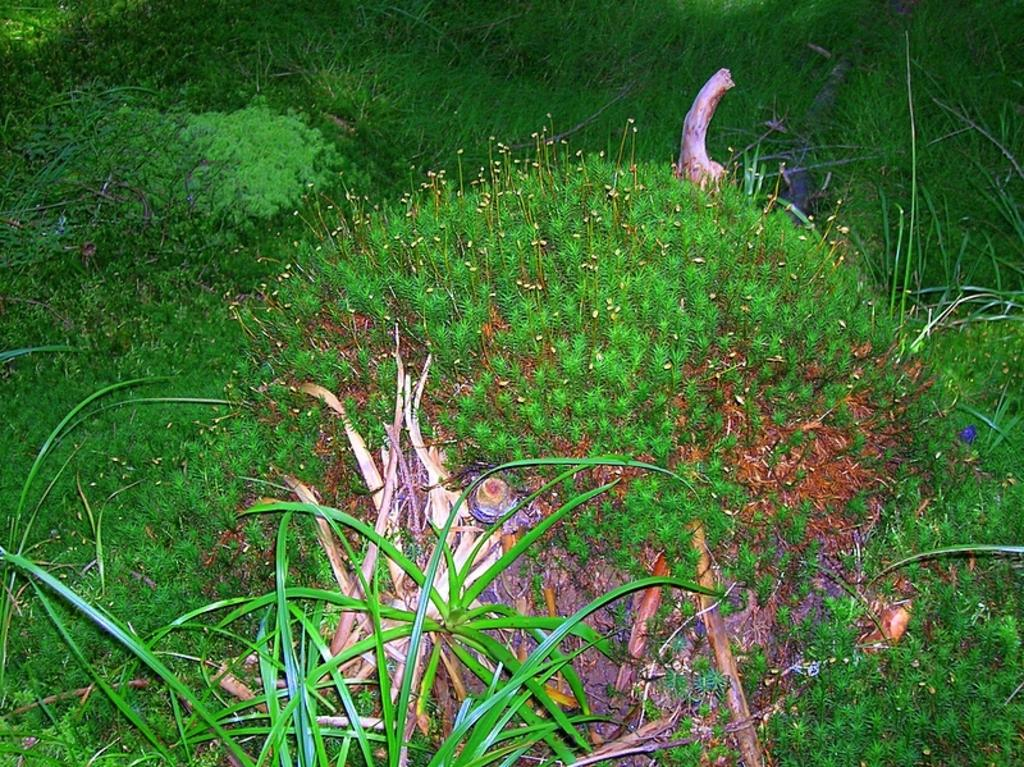What type of vegetation can be seen in the image? There are bushes and grass in the image. Can you describe the ground in the image? The ground is covered with grass. What type of leaf can be seen on the bushes in the image? There is no specific leaf mentioned or visible in the image; it only shows bushes and grass. 